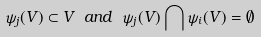<formula> <loc_0><loc_0><loc_500><loc_500>\psi _ { j } ( V ) \subset V \ a n d \ \psi _ { j } ( V ) \bigcap \psi _ { i } ( V ) = \emptyset</formula> 